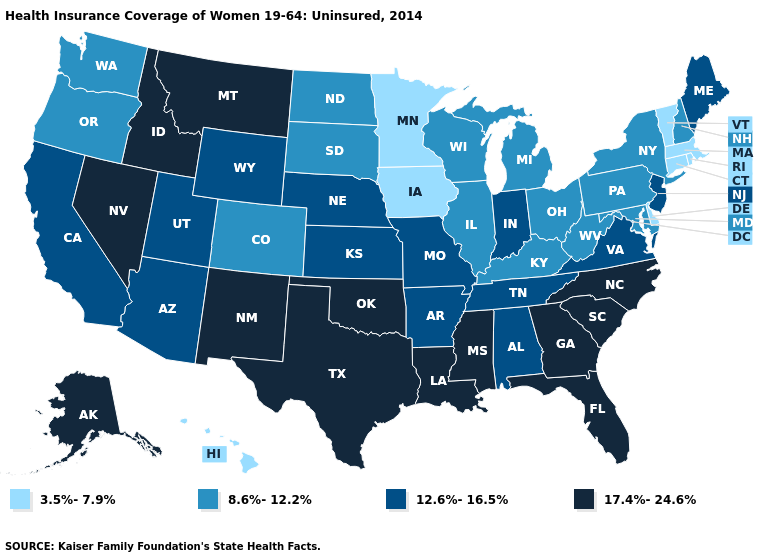What is the value of Ohio?
Be succinct. 8.6%-12.2%. What is the value of Oklahoma?
Write a very short answer. 17.4%-24.6%. Name the states that have a value in the range 17.4%-24.6%?
Answer briefly. Alaska, Florida, Georgia, Idaho, Louisiana, Mississippi, Montana, Nevada, New Mexico, North Carolina, Oklahoma, South Carolina, Texas. Among the states that border Indiana , which have the lowest value?
Answer briefly. Illinois, Kentucky, Michigan, Ohio. What is the value of Pennsylvania?
Write a very short answer. 8.6%-12.2%. What is the highest value in the USA?
Short answer required. 17.4%-24.6%. What is the value of South Carolina?
Short answer required. 17.4%-24.6%. Does South Dakota have the highest value in the USA?
Give a very brief answer. No. What is the highest value in the USA?
Answer briefly. 17.4%-24.6%. What is the highest value in the USA?
Be succinct. 17.4%-24.6%. Name the states that have a value in the range 12.6%-16.5%?
Write a very short answer. Alabama, Arizona, Arkansas, California, Indiana, Kansas, Maine, Missouri, Nebraska, New Jersey, Tennessee, Utah, Virginia, Wyoming. What is the value of Texas?
Be succinct. 17.4%-24.6%. Does New Hampshire have a higher value than Kentucky?
Be succinct. No. What is the lowest value in states that border Washington?
Keep it brief. 8.6%-12.2%. Among the states that border Oklahoma , which have the highest value?
Concise answer only. New Mexico, Texas. 